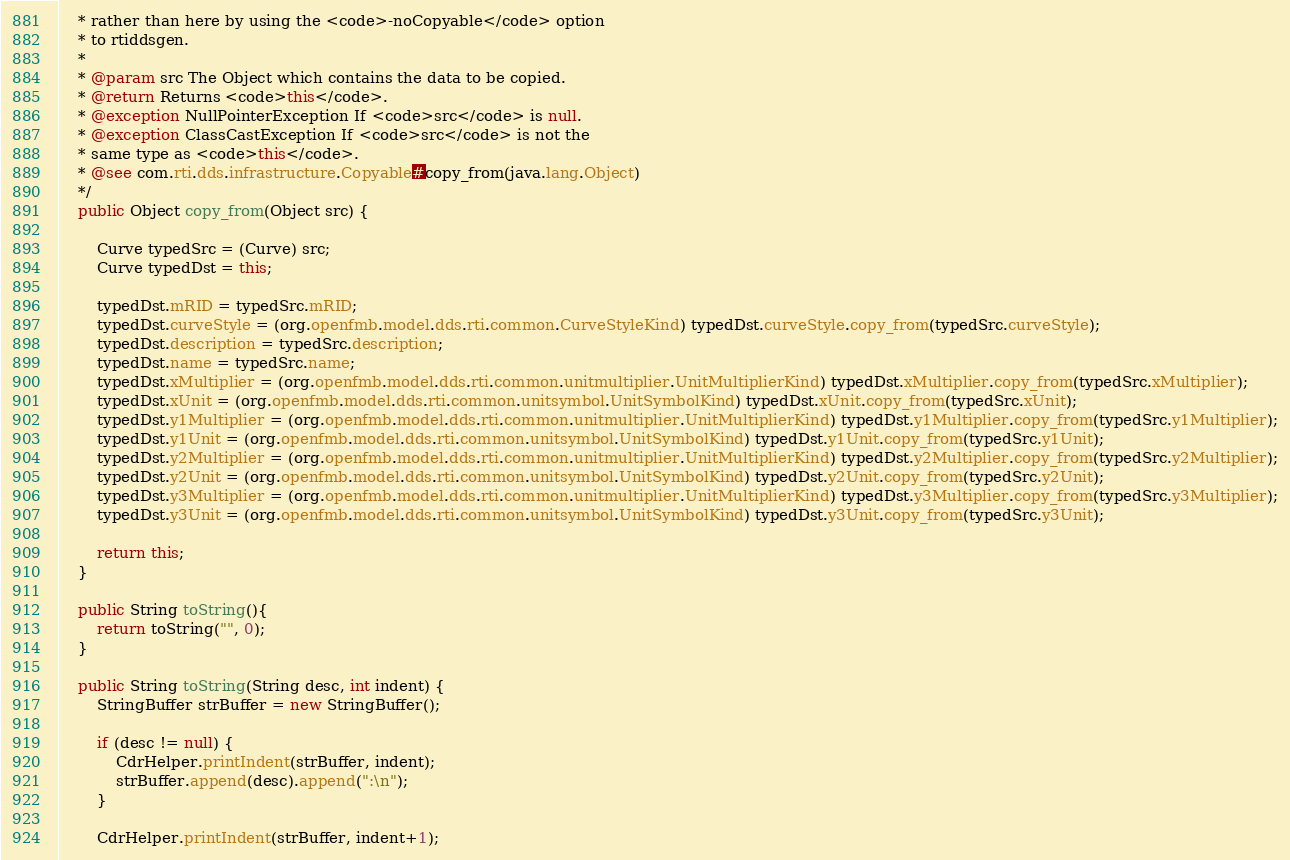<code> <loc_0><loc_0><loc_500><loc_500><_Java_>    * rather than here by using the <code>-noCopyable</code> option
    * to rtiddsgen.
    * 
    * @param src The Object which contains the data to be copied.
    * @return Returns <code>this</code>.
    * @exception NullPointerException If <code>src</code> is null.
    * @exception ClassCastException If <code>src</code> is not the 
    * same type as <code>this</code>.
    * @see com.rti.dds.infrastructure.Copyable#copy_from(java.lang.Object)
    */
    public Object copy_from(Object src) {

        Curve typedSrc = (Curve) src;
        Curve typedDst = this;

        typedDst.mRID = typedSrc.mRID;
        typedDst.curveStyle = (org.openfmb.model.dds.rti.common.CurveStyleKind) typedDst.curveStyle.copy_from(typedSrc.curveStyle);
        typedDst.description = typedSrc.description;
        typedDst.name = typedSrc.name;
        typedDst.xMultiplier = (org.openfmb.model.dds.rti.common.unitmultiplier.UnitMultiplierKind) typedDst.xMultiplier.copy_from(typedSrc.xMultiplier);
        typedDst.xUnit = (org.openfmb.model.dds.rti.common.unitsymbol.UnitSymbolKind) typedDst.xUnit.copy_from(typedSrc.xUnit);
        typedDst.y1Multiplier = (org.openfmb.model.dds.rti.common.unitmultiplier.UnitMultiplierKind) typedDst.y1Multiplier.copy_from(typedSrc.y1Multiplier);
        typedDst.y1Unit = (org.openfmb.model.dds.rti.common.unitsymbol.UnitSymbolKind) typedDst.y1Unit.copy_from(typedSrc.y1Unit);
        typedDst.y2Multiplier = (org.openfmb.model.dds.rti.common.unitmultiplier.UnitMultiplierKind) typedDst.y2Multiplier.copy_from(typedSrc.y2Multiplier);
        typedDst.y2Unit = (org.openfmb.model.dds.rti.common.unitsymbol.UnitSymbolKind) typedDst.y2Unit.copy_from(typedSrc.y2Unit);
        typedDst.y3Multiplier = (org.openfmb.model.dds.rti.common.unitmultiplier.UnitMultiplierKind) typedDst.y3Multiplier.copy_from(typedSrc.y3Multiplier);
        typedDst.y3Unit = (org.openfmb.model.dds.rti.common.unitsymbol.UnitSymbolKind) typedDst.y3Unit.copy_from(typedSrc.y3Unit);

        return this;
    }

    public String toString(){
        return toString("", 0);
    }

    public String toString(String desc, int indent) {
        StringBuffer strBuffer = new StringBuffer();        

        if (desc != null) {
            CdrHelper.printIndent(strBuffer, indent);
            strBuffer.append(desc).append(":\n");
        }

        CdrHelper.printIndent(strBuffer, indent+1);        </code> 